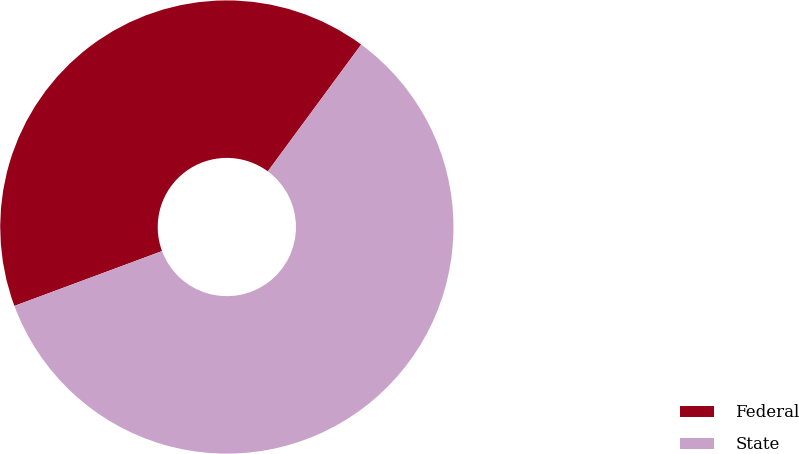<chart> <loc_0><loc_0><loc_500><loc_500><pie_chart><fcel>Federal<fcel>State<nl><fcel>40.76%<fcel>59.24%<nl></chart> 